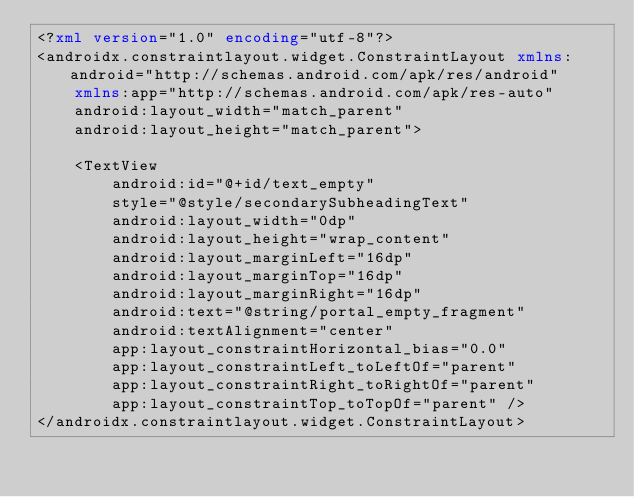<code> <loc_0><loc_0><loc_500><loc_500><_XML_><?xml version="1.0" encoding="utf-8"?>
<androidx.constraintlayout.widget.ConstraintLayout xmlns:android="http://schemas.android.com/apk/res/android"
    xmlns:app="http://schemas.android.com/apk/res-auto"
    android:layout_width="match_parent"
    android:layout_height="match_parent">

    <TextView
        android:id="@+id/text_empty"
        style="@style/secondarySubheadingText"
        android:layout_width="0dp"
        android:layout_height="wrap_content"
        android:layout_marginLeft="16dp"
        android:layout_marginTop="16dp"
        android:layout_marginRight="16dp"
        android:text="@string/portal_empty_fragment"
        android:textAlignment="center"
        app:layout_constraintHorizontal_bias="0.0"
        app:layout_constraintLeft_toLeftOf="parent"
        app:layout_constraintRight_toRightOf="parent"
        app:layout_constraintTop_toTopOf="parent" />
</androidx.constraintlayout.widget.ConstraintLayout></code> 